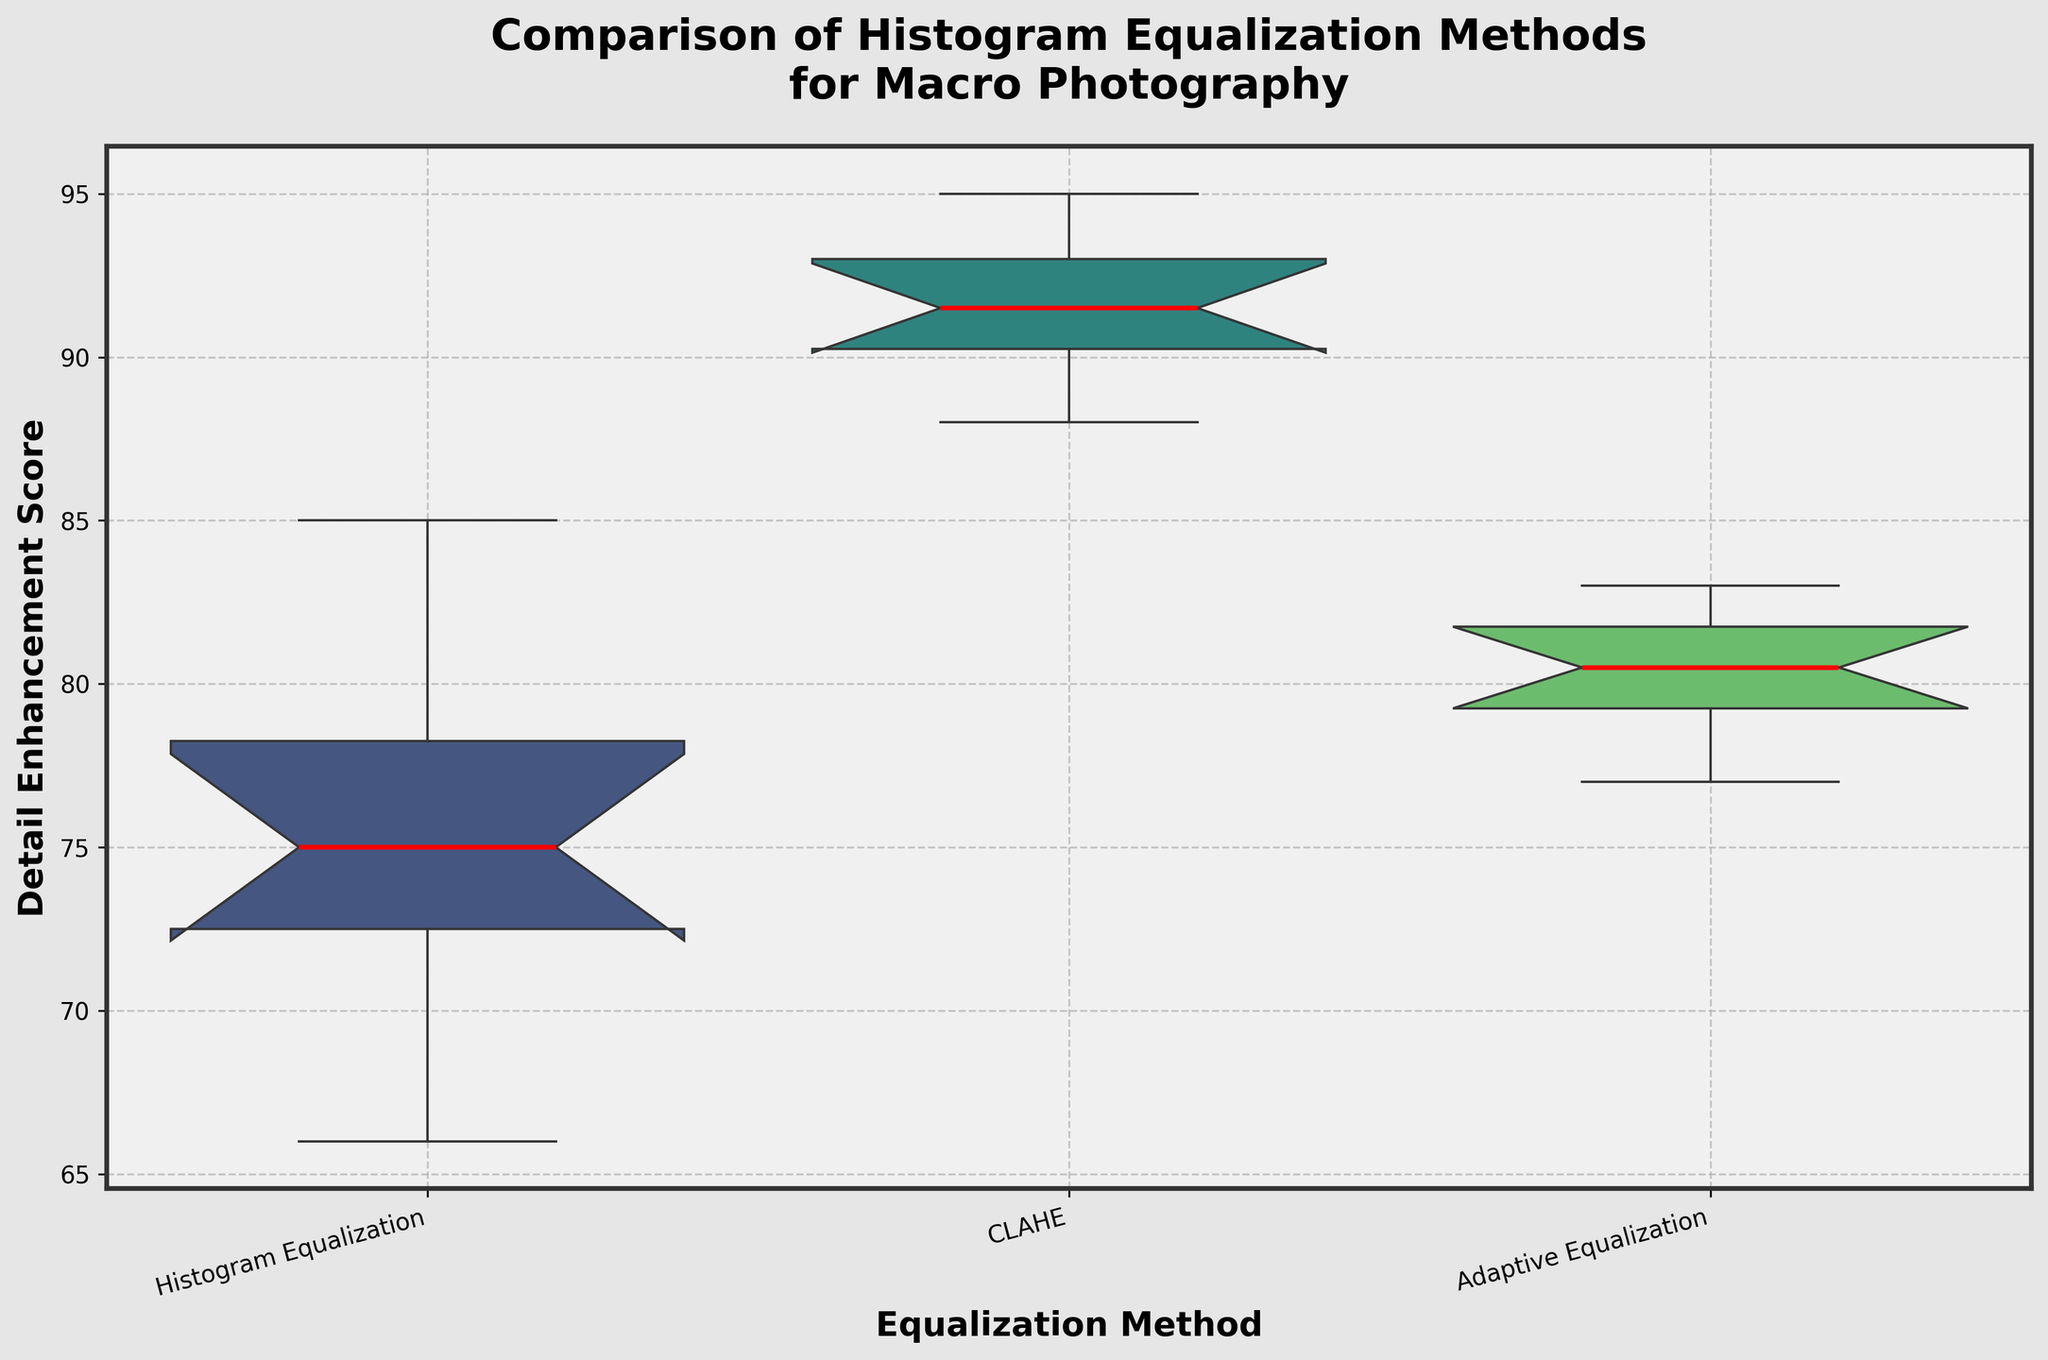What is the title of the figure? The title of the figure is written at the top of the plot. It reads 'Comparison of Histogram Equalization Methods for Macro Photography'.
Answer: Comparison of Histogram Equalization Methods for Macro Photography Which equalization method has the highest median Detail Enhancement Score? The notched box plot shows median values with red lines. The CLAHE method has the highest median value because its red line is higher than those of Histogram Equalization and Adaptive Equalization methods.
Answer: CLAHE Which equalization method has the most consistent results, indicated by the shortest interquartile range? The interquartile range is represented by the box's height. The CLAHE method has the shortest box, indicating the smallest interquartile range. This suggests CLAHE has the most consistent results.
Answer: CLAHE What value represents the median Detail Enhancement Score for the Adaptive Equalization method? The median value for each method is indicated by the red line within each box. For the Adaptive Equalization method, the red line is at about 80.
Answer: Approximately 80 Which equalization method shows the most variability in Detail Enhancement Scores? Variability is indicated by the length of the whiskers and the presence of outliers. Histogram Equalization shows the most variability because it has the longest whiskers and multiple outliers.
Answer: Histogram Equalization Are there any outliers present in the data for any method? Outliers are represented by diamond markers. There are outliers present in the Histogram Equalization method, as indicated by white diamonds.
Answer: Yes How do the median Detail Enhancement Scores of Histogram Equalization and Adaptive Equalization compare? The red lines on the notched box plot represent the median scores. The median score of Adaptive Equalization is slightly higher than that of Histogram Equalization.
Answer: Adaptive Equalization is higher What can be concluded about the effectiveness of CLAHE compared to the other methods based on the notched box plot? CLAHE has the highest median value, the shortest interquartile range, and a higher overall performance indicated by its position on the y-axis. This suggests that CLAHE is the most effective method compared to Histogram Equalization and Adaptive Equalization.
Answer: CLAHE is the most effective method 